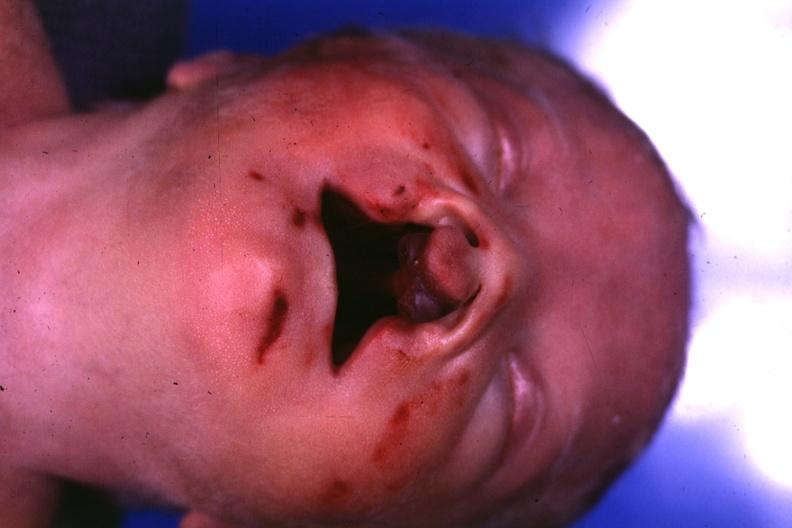what is present?
Answer the question using a single word or phrase. Face 